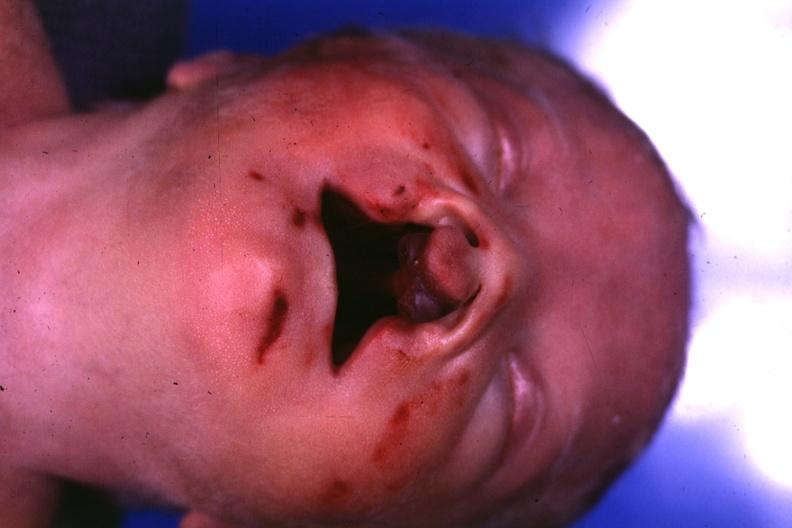what is present?
Answer the question using a single word or phrase. Face 